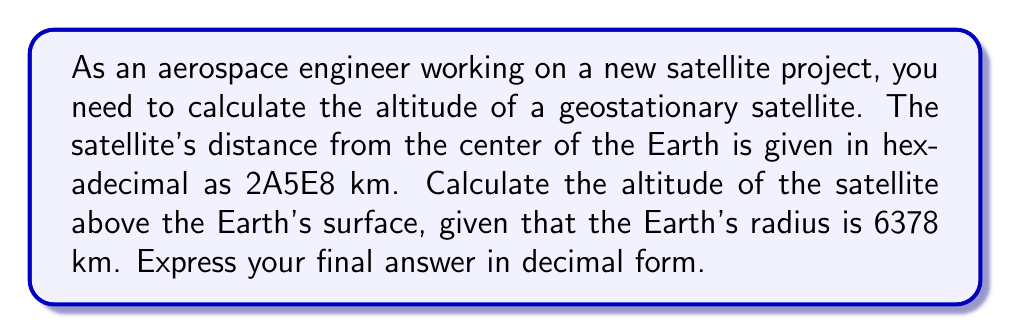Solve this math problem. To solve this problem, we need to follow these steps:

1. Convert the hexadecimal distance to decimal:
   $2A5E8_{16} = 2 \times 16^4 + 10 \times 16^3 + 5 \times 16^2 + 14 \times 16^1 + 8 \times 16^0$
   $= 2 \times 65536 + 10 \times 4096 + 5 \times 256 + 14 \times 16 + 8 \times 1$
   $= 131072 + 40960 + 1280 + 224 + 8$
   $= 173544$ km

2. Calculate the altitude by subtracting the Earth's radius:
   Altitude = Satellite distance from Earth's center - Earth's radius
   $= 173544 - 6378$ km

3. Perform the subtraction:
   $173544 - 6378 = 167166$ km

Therefore, the altitude of the geostationary satellite is 167166 km above the Earth's surface.
Answer: The altitude of the geostationary satellite is 167166 km. 